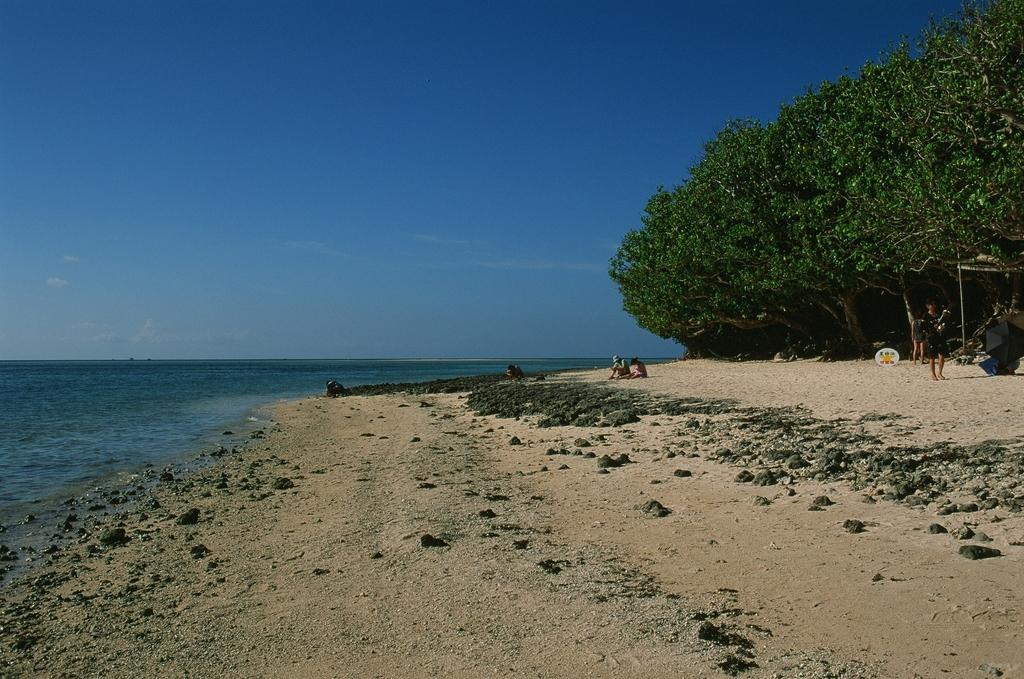What type of vegetation can be seen in the image? There are trees in the image. What are the people in the image doing? The people are seated on the ground in the image. Can you describe the person standing in the image? There is a person standing in the image. What object is visible for providing shade or protection from the elements? An umbrella is visible in the image. What is the nature of the water in the image? Water is present in the image. How would you describe the sky in the image? The sky is blue and cloudy in the image. What verse is being recited by the trees in the image? There are no verses being recited by the trees in the image; they are simply trees. How many hands are visible in the image? The number of hands visible in the image cannot be determined from the provided facts, as it depends on the number of people present and their body positions. 